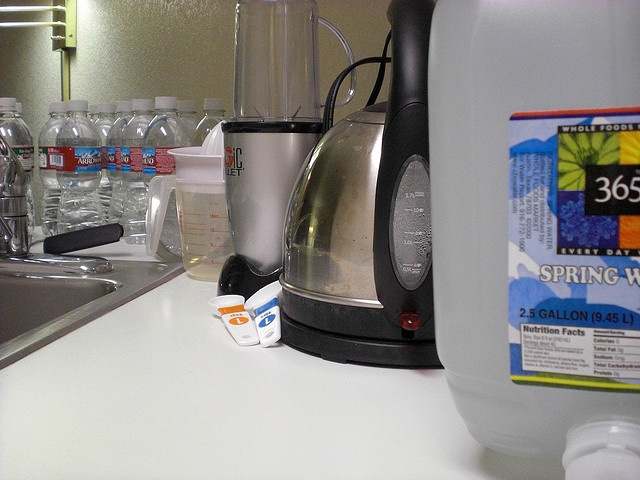Describe the objects in this image and their specific colors. I can see cup in gray, darkgray, and black tones, sink in gray and black tones, bottle in gray, darkgray, and maroon tones, bottle in gray and darkgray tones, and bottle in gray, darkgray, and black tones in this image. 